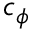Convert formula to latex. <formula><loc_0><loc_0><loc_500><loc_500>c _ { \phi }</formula> 